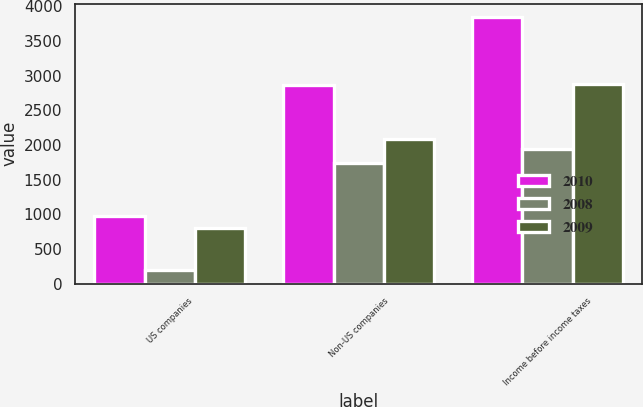Convert chart. <chart><loc_0><loc_0><loc_500><loc_500><stacked_bar_chart><ecel><fcel>US companies<fcel>Non-US companies<fcel>Income before income taxes<nl><fcel>2010<fcel>975<fcel>2870<fcel>3845<nl><fcel>2008<fcel>202<fcel>1732<fcel>1934<nl><fcel>2009<fcel>801<fcel>2081<fcel>2882<nl></chart> 